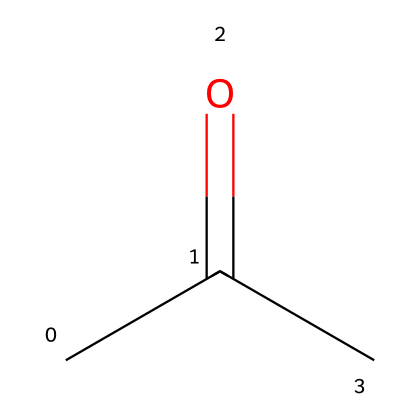What is the common name of this chemical? This chemical is represented by the SMILES notation CC(=O)C, which corresponds to acetone, a well-known solvent.
Answer: acetone How many carbon atoms are present in the structure? The SMILES notation CC(=O)C indicates the presence of three carbon atoms, as each 'C' represents a carbon atom in the structure.
Answer: three How many oxygen atoms does this compound contain? In the SMILES CC(=O)C, there is one 'O' present, which indicates that this chemical contains one oxygen atom.
Answer: one What type of functional group is present in this structure? The structure contains a carbonyl group (C=O) which is characteristic of ketones, including acetone. Since the carbonyl is flanked by carbon atoms, it confirms the functional type of this compound.
Answer: ketone What is the degree of saturation for the molecule? To determine the degree of saturation, one can analyze the number of double bonds and rings; the structure contains one double bond (C=O) and is open-chain with no rings, indicating it is fully saturated apart from the double bond, which contributes to it being a ketone.
Answer: one double bond What is a primary use of acetone as a solvent? Acetone is widely used as a cleaning agent for electronic components due to its ability to dissolve oils and residues without leaving harmful residues.
Answer: cleaning electronic components Is acetone polar or nonpolar? The structure of acetone, with its carbonyl group and overall molecular arrangement, indicates that it is polar, allowing it to interact with various polar solvents and substances.
Answer: polar 